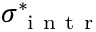<formula> <loc_0><loc_0><loc_500><loc_500>\sigma _ { i n t r } ^ { \ast }</formula> 